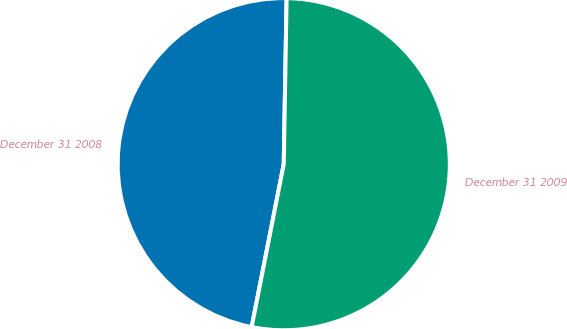Convert chart to OTSL. <chart><loc_0><loc_0><loc_500><loc_500><pie_chart><fcel>December 31 2008<fcel>December 31 2009<nl><fcel>47.18%<fcel>52.82%<nl></chart> 